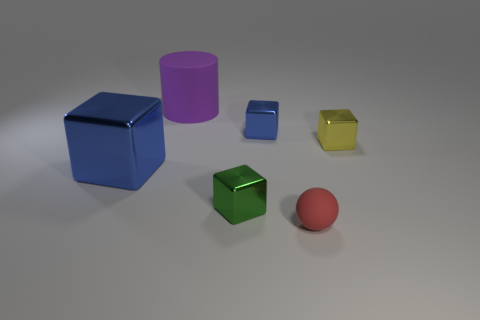Subtract all purple balls. Subtract all brown blocks. How many balls are left? 1 Add 2 tiny cubes. How many objects exist? 8 Subtract all spheres. How many objects are left? 5 Add 4 big yellow matte cubes. How many big yellow matte cubes exist? 4 Subtract 1 purple cylinders. How many objects are left? 5 Subtract all tiny yellow metallic cubes. Subtract all green blocks. How many objects are left? 4 Add 2 matte cylinders. How many matte cylinders are left? 3 